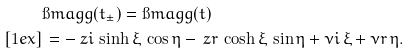<formula> <loc_0><loc_0><loc_500><loc_500>& \i m a g g ( t _ { \pm } ) = \i m a g g ( t ) \\ [ 1 e x ] & \, = - \ z i \, \sinh \xi \, \cos \eta - \ z r \, \cosh \xi \, \sin \eta + \nu i \, \xi + \nu r \, \eta .</formula> 